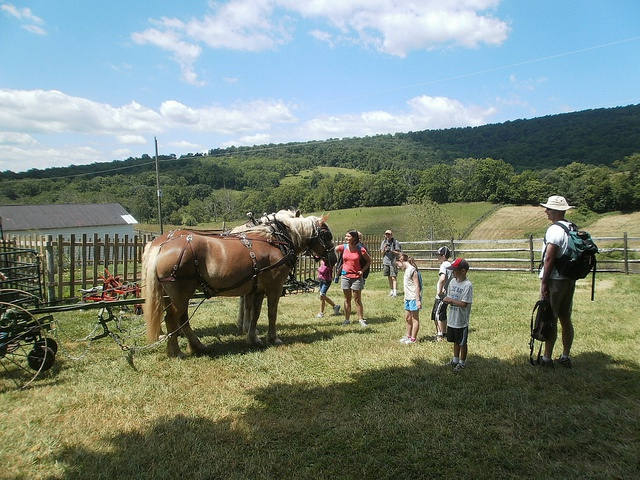Describe the objects in this image and their specific colors. I can see horse in lightblue, black, gray, maroon, and tan tones, people in lightblue, black, white, gray, and darkgray tones, people in lightblue, maroon, black, and gray tones, people in lightblue, black, gray, darkgray, and maroon tones, and backpack in lightblue, black, gray, and teal tones in this image. 